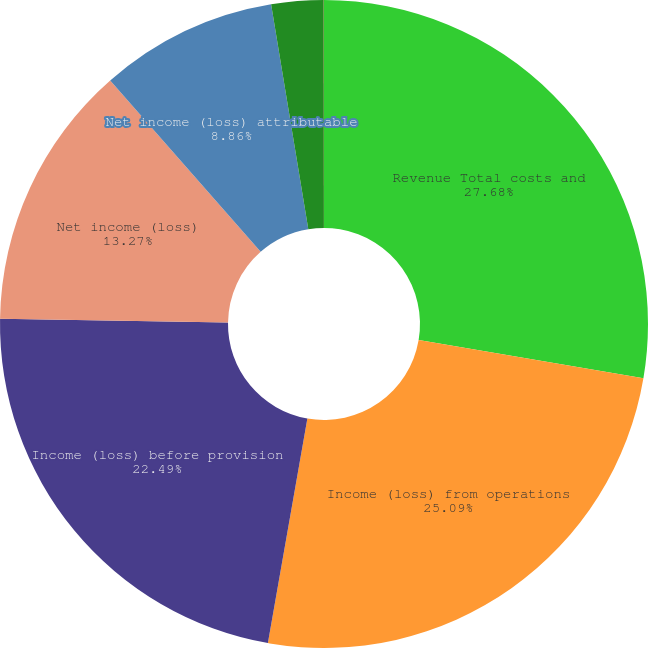Convert chart to OTSL. <chart><loc_0><loc_0><loc_500><loc_500><pie_chart><fcel>Revenue Total costs and<fcel>Income (loss) from operations<fcel>Income (loss) before provision<fcel>Net income (loss)<fcel>Net income (loss) attributable<fcel>Basic<fcel>Diluted<nl><fcel>27.68%<fcel>25.09%<fcel>22.49%<fcel>13.27%<fcel>8.86%<fcel>2.6%<fcel>0.01%<nl></chart> 